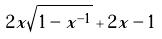<formula> <loc_0><loc_0><loc_500><loc_500>2 x \sqrt { 1 - x ^ { - 1 } } + 2 x - 1</formula> 